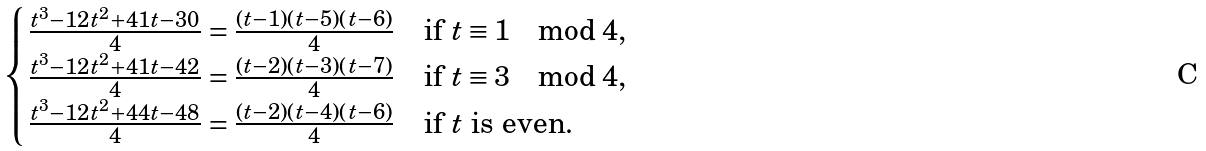<formula> <loc_0><loc_0><loc_500><loc_500>\begin{cases} \frac { t ^ { 3 } - 1 2 t ^ { 2 } + 4 1 t - 3 0 } { 4 } = \frac { ( t - 1 ) ( t - 5 ) ( t - 6 ) } { 4 } & \text {if } t \equiv 1 \mod 4 , \\ \frac { t ^ { 3 } - 1 2 t ^ { 2 } + 4 1 t - 4 2 } { 4 } = \frac { ( t - 2 ) ( t - 3 ) ( t - 7 ) } { 4 } & \text {if } t \equiv 3 \mod 4 , \\ \frac { t ^ { 3 } - 1 2 t ^ { 2 } + 4 4 t - 4 8 } { 4 } = \frac { ( t - 2 ) ( t - 4 ) ( t - 6 ) } { 4 } & \text {if $t$ is even} . \end{cases}</formula> 